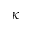<formula> <loc_0><loc_0><loc_500><loc_500>\kappa</formula> 